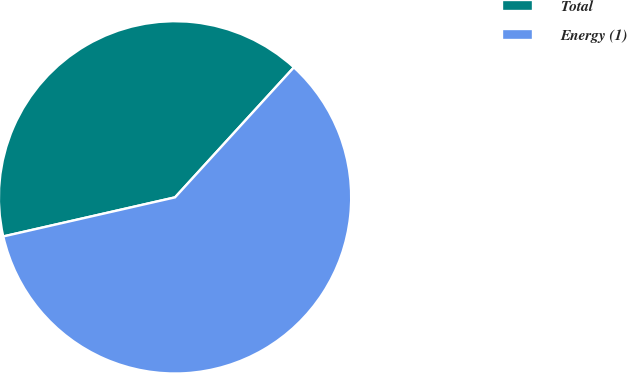Convert chart to OTSL. <chart><loc_0><loc_0><loc_500><loc_500><pie_chart><fcel>Total<fcel>Energy (1)<nl><fcel>40.35%<fcel>59.65%<nl></chart> 